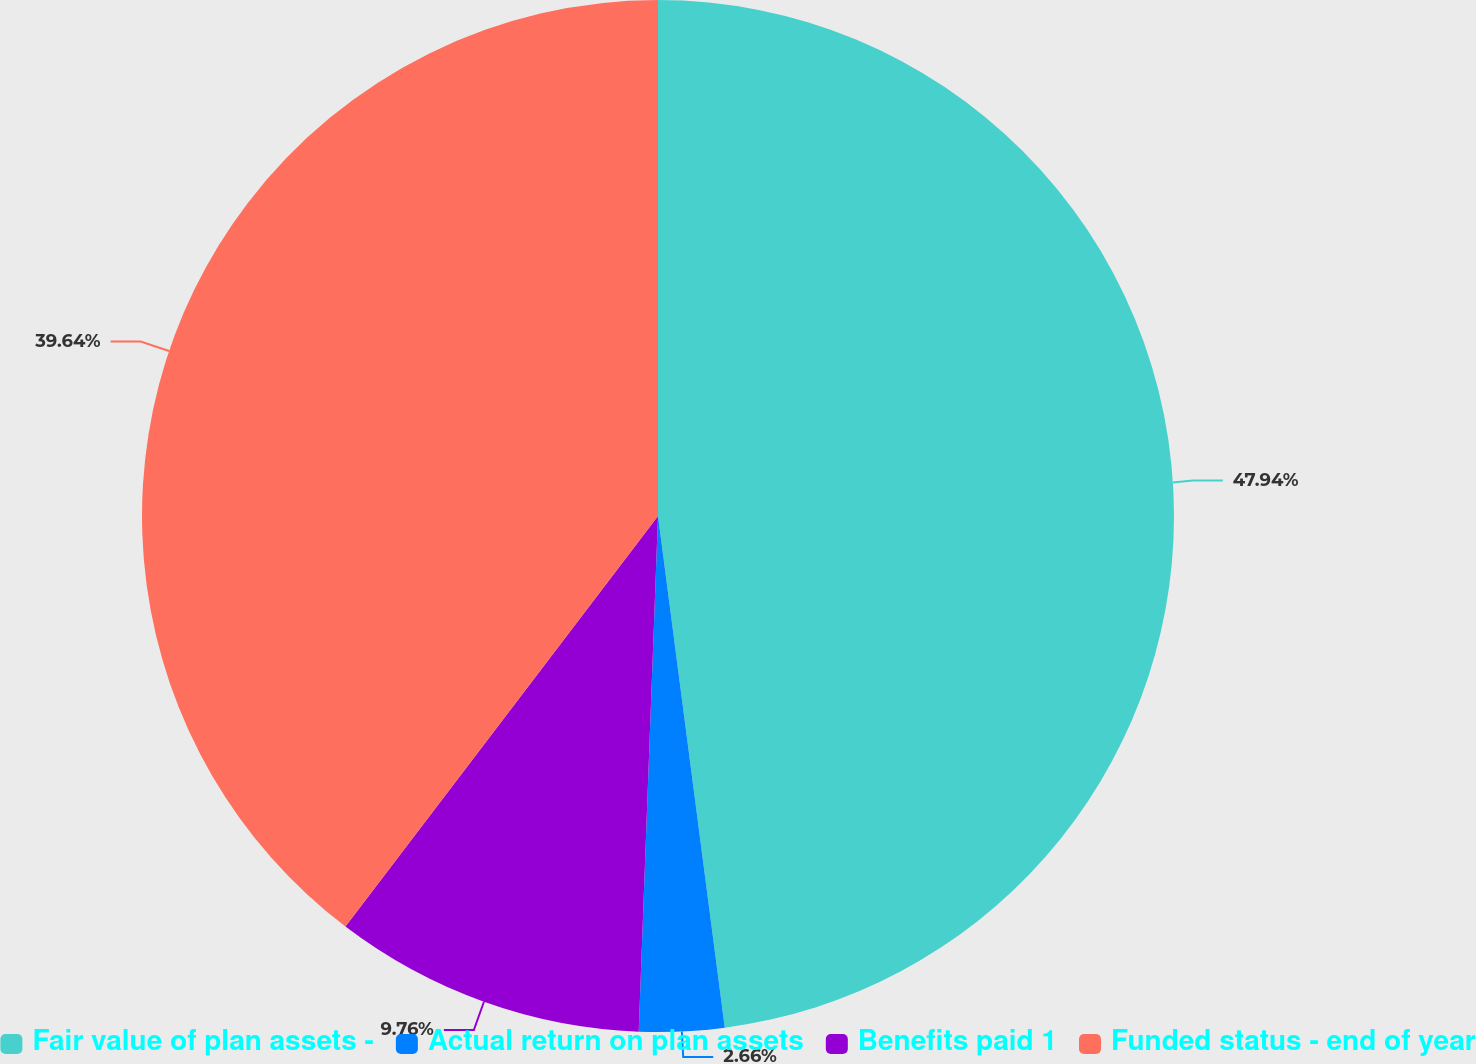Convert chart to OTSL. <chart><loc_0><loc_0><loc_500><loc_500><pie_chart><fcel>Fair value of plan assets -<fcel>Actual return on plan assets<fcel>Benefits paid 1<fcel>Funded status - end of year<nl><fcel>47.93%<fcel>2.66%<fcel>9.76%<fcel>39.64%<nl></chart> 